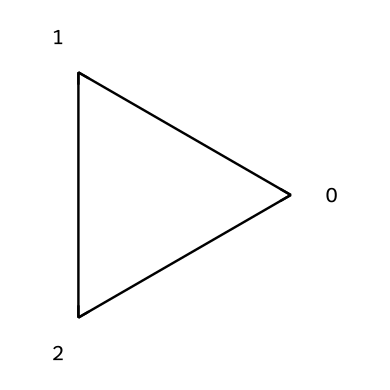What is the chemical name of this compound? The SMILES representation "C1CC1" corresponds to a three-carbon ring with single bonds, which is named cyclopropane.
Answer: cyclopropane How many carbon atoms are present in the structure? The SMILES notation indicates three carbon atoms (C) forming a cyclic structure, as seen by the "C1CC1" pattern, which represents a closed loop of three carbons.
Answer: 3 How many hydrogen atoms are bonded to the carbon atoms in cyclopropane? Cyclopropane is a fully saturated cyclic alkane. Each carbon in this structure is bonded to two hydrogen atoms, resulting in a total of six hydrogen atoms (3 carbons * 2 hydrogens each).
Answer: 6 What is the total number of rings in cyclopropane? The SMILES notation "C1CC1" reveals a single cyclic structure, indicating that there is one ring in this compound.
Answer: 1 Is cyclopropane a saturated or unsaturated hydrocarbon? Cyclopropane contains only single bonds between its carbon atoms and has no double or triple bonds, categorizing it as a saturated hydrocarbon.
Answer: saturated What type of cyclic compound is cyclopropane classified as? Cyclopropane is a cycloalkane because it is a cyclic alkane, which consists solely of carbon and hydrogen atoms connected with single bonds.
Answer: cycloalkane 